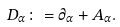<formula> <loc_0><loc_0><loc_500><loc_500>\ D _ { \alpha } \colon = \partial _ { \alpha } + A _ { \alpha } .</formula> 